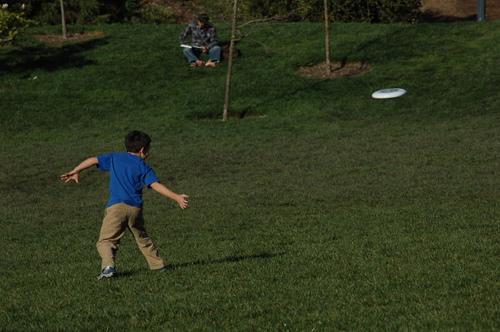Is the boy posing for a photo?
Be succinct. No. Is the young boy playing baseball?
Short answer required. No. Is the frisbee normal size?
Be succinct. Yes. What color of shirt is the young boy wearing?
Concise answer only. Blue. What is the boy throwing?
Short answer required. Frisbee. How many people are watching the game?
Answer briefly. 1. How many kids are there?
Keep it brief. 1. Is the little boy wearing shoes?
Write a very short answer. Yes. Is the thrower a boy or a girl?
Give a very brief answer. Boy. Is the child teaching the man how to play frisbee?
Concise answer only. No. What color is his outfit?
Write a very short answer. Blue and brown. Is the boy wearing shorts or pants?
Quick response, please. Pants. Is it cold outside?
Quick response, please. No. What color shirt is he wearing?
Be succinct. Blue. What game do the people play?
Quick response, please. Frisbee. Is this a little boy or girl?
Keep it brief. Boy. What is the child wearing on his head?
Be succinct. Nothing. Are they on a path or wandering through the grass?
Short answer required. Grass. What have they pitched on the field?
Write a very short answer. Frisbee. Is there a ball in the photo?
Short answer required. No. Is the ball in motion?
Keep it brief. No ball. What is in the air?
Answer briefly. Frisbee. Are there trees in the picture?
Write a very short answer. Yes. What sport is the boy playing?
Quick response, please. Frisbee. What color is the child's shirt?
Short answer required. Blue. What color is the frisbee?
Answer briefly. White. How many people in the shot?
Be succinct. 2. What is the person in the picture doing?
Concise answer only. Throwing frisbee. Is the Frisbee moving left to right?
Concise answer only. Yes. What is the boy doing?
Concise answer only. Playing frisbee. Is the person wearing long pants?
Quick response, please. Yes. Is there a device in the photo for camping out?
Write a very short answer. No. Is there more than one child in the picture?
Write a very short answer. No. Is he a good thrower?
Answer briefly. Yes. What are they playing?
Quick response, please. Frisbee. 